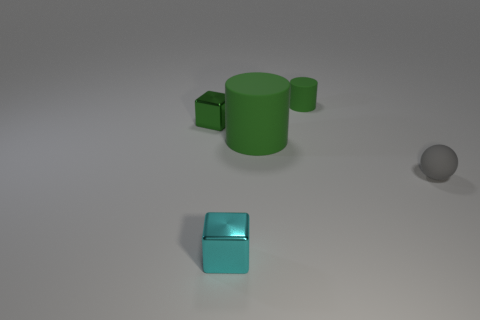Are there more big green rubber things that are in front of the gray matte ball than rubber cylinders that are behind the green metallic object?
Your response must be concise. No. The metal thing that is to the left of the tiny cyan metal thing is what color?
Give a very brief answer. Green. Is there a big purple rubber thing of the same shape as the small gray object?
Ensure brevity in your answer.  No. How many purple things are either spheres or large matte cylinders?
Offer a very short reply. 0. Is there a cube that has the same size as the matte ball?
Give a very brief answer. Yes. How many large things are there?
Your answer should be compact. 1. What number of tiny things are brown shiny spheres or green objects?
Make the answer very short. 2. There is a cylinder that is left of the matte cylinder that is behind the small metallic block that is left of the cyan cube; what color is it?
Your response must be concise. Green. What number of other things are there of the same color as the small matte sphere?
Your answer should be compact. 0. How many rubber things are either large red cylinders or tiny spheres?
Provide a succinct answer. 1. 